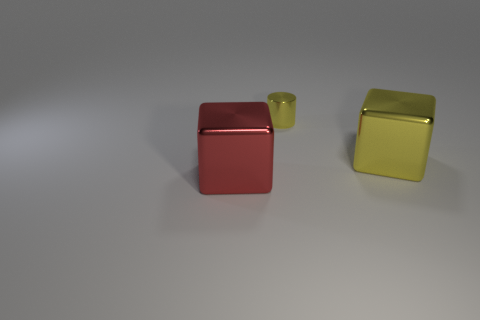Is the number of things that are left of the large red metallic cube less than the number of yellow things that are behind the big yellow metallic object?
Provide a short and direct response. Yes. Is there anything else that is the same shape as the large red metallic thing?
Ensure brevity in your answer.  Yes. There is a large thing that is the same color as the cylinder; what is its material?
Offer a very short reply. Metal. There is a large shiny thing on the right side of the object in front of the big yellow thing; what number of big yellow metal things are behind it?
Offer a very short reply. 0. There is a tiny thing; what number of cubes are behind it?
Provide a succinct answer. 0. What number of other large blocks have the same material as the large red block?
Provide a succinct answer. 1. What is the color of the tiny thing that is the same material as the large yellow object?
Ensure brevity in your answer.  Yellow. The large object that is behind the cube in front of the shiny block that is behind the red metal thing is made of what material?
Give a very brief answer. Metal. Do the thing to the left of the yellow shiny cylinder and the small yellow shiny thing have the same size?
Make the answer very short. No. How many small objects are either yellow metal blocks or red things?
Ensure brevity in your answer.  0. 